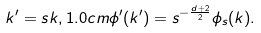Convert formula to latex. <formula><loc_0><loc_0><loc_500><loc_500>k ^ { \prime } = s k , 1 . 0 c m \phi ^ { \prime } ( k ^ { \prime } ) = s ^ { - \frac { d + 2 } { 2 } } \phi _ { s } ( k ) .</formula> 